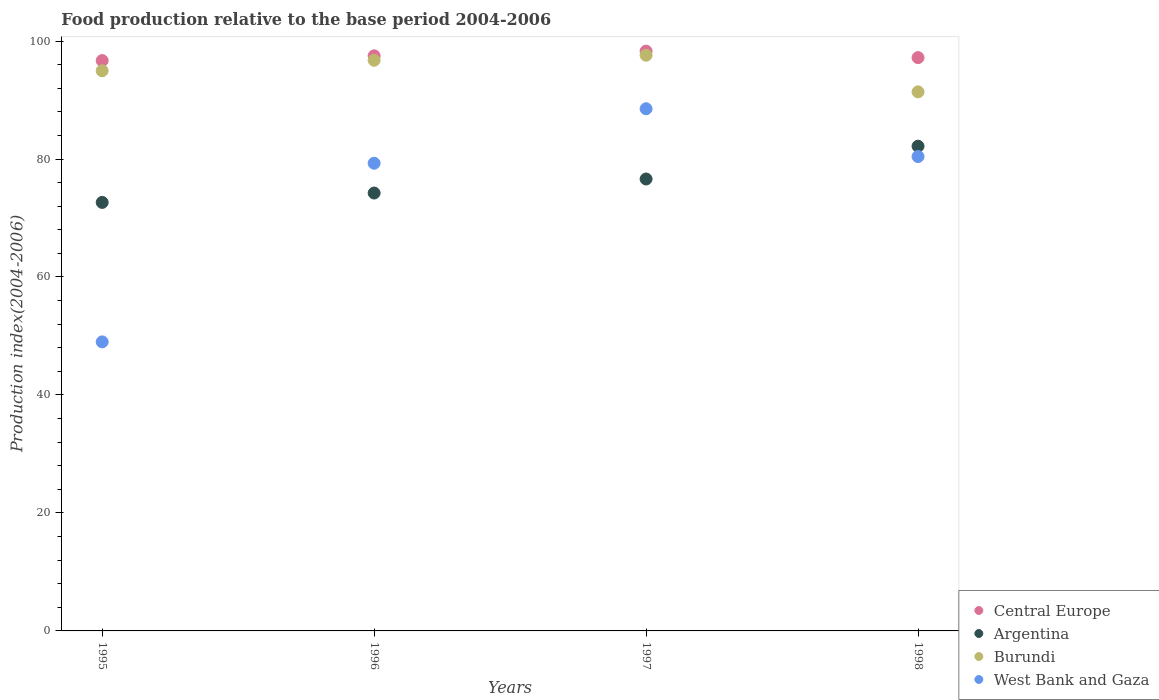How many different coloured dotlines are there?
Provide a succinct answer. 4. Is the number of dotlines equal to the number of legend labels?
Ensure brevity in your answer.  Yes. What is the food production index in Argentina in 1996?
Give a very brief answer. 74.23. Across all years, what is the maximum food production index in Central Europe?
Keep it short and to the point. 98.29. Across all years, what is the minimum food production index in Argentina?
Your answer should be compact. 72.64. In which year was the food production index in Burundi minimum?
Your response must be concise. 1998. What is the total food production index in Central Europe in the graph?
Offer a terse response. 389.66. What is the difference between the food production index in West Bank and Gaza in 1995 and that in 1997?
Your answer should be compact. -39.52. What is the difference between the food production index in West Bank and Gaza in 1998 and the food production index in Central Europe in 1997?
Make the answer very short. -17.87. What is the average food production index in West Bank and Gaza per year?
Your answer should be compact. 74.31. In the year 1995, what is the difference between the food production index in Argentina and food production index in Central Europe?
Give a very brief answer. -24.04. In how many years, is the food production index in Central Europe greater than 28?
Your answer should be very brief. 4. What is the ratio of the food production index in West Bank and Gaza in 1995 to that in 1996?
Provide a succinct answer. 0.62. Is the food production index in Burundi in 1995 less than that in 1997?
Give a very brief answer. Yes. Is the difference between the food production index in Argentina in 1995 and 1996 greater than the difference between the food production index in Central Europe in 1995 and 1996?
Keep it short and to the point. No. What is the difference between the highest and the second highest food production index in West Bank and Gaza?
Your response must be concise. 8.1. What is the difference between the highest and the lowest food production index in Central Europe?
Give a very brief answer. 1.61. Is the sum of the food production index in West Bank and Gaza in 1995 and 1998 greater than the maximum food production index in Argentina across all years?
Keep it short and to the point. Yes. Is the food production index in Argentina strictly less than the food production index in Central Europe over the years?
Ensure brevity in your answer.  Yes. How many dotlines are there?
Provide a short and direct response. 4. What is the difference between two consecutive major ticks on the Y-axis?
Your answer should be very brief. 20. Are the values on the major ticks of Y-axis written in scientific E-notation?
Your response must be concise. No. Does the graph contain any zero values?
Provide a succinct answer. No. How are the legend labels stacked?
Your answer should be compact. Vertical. What is the title of the graph?
Your answer should be very brief. Food production relative to the base period 2004-2006. Does "Mali" appear as one of the legend labels in the graph?
Make the answer very short. No. What is the label or title of the Y-axis?
Your response must be concise. Production index(2004-2006). What is the Production index(2004-2006) of Central Europe in 1995?
Make the answer very short. 96.68. What is the Production index(2004-2006) of Argentina in 1995?
Offer a very short reply. 72.64. What is the Production index(2004-2006) in Burundi in 1995?
Keep it short and to the point. 94.96. What is the Production index(2004-2006) in Central Europe in 1996?
Make the answer very short. 97.49. What is the Production index(2004-2006) of Argentina in 1996?
Offer a very short reply. 74.23. What is the Production index(2004-2006) in Burundi in 1996?
Make the answer very short. 96.74. What is the Production index(2004-2006) of West Bank and Gaza in 1996?
Offer a very short reply. 79.28. What is the Production index(2004-2006) of Central Europe in 1997?
Provide a short and direct response. 98.29. What is the Production index(2004-2006) in Argentina in 1997?
Your response must be concise. 76.61. What is the Production index(2004-2006) of Burundi in 1997?
Provide a succinct answer. 97.59. What is the Production index(2004-2006) of West Bank and Gaza in 1997?
Provide a succinct answer. 88.52. What is the Production index(2004-2006) in Central Europe in 1998?
Keep it short and to the point. 97.19. What is the Production index(2004-2006) of Argentina in 1998?
Offer a terse response. 82.17. What is the Production index(2004-2006) in Burundi in 1998?
Keep it short and to the point. 91.38. What is the Production index(2004-2006) in West Bank and Gaza in 1998?
Make the answer very short. 80.42. Across all years, what is the maximum Production index(2004-2006) in Central Europe?
Provide a short and direct response. 98.29. Across all years, what is the maximum Production index(2004-2006) in Argentina?
Your answer should be compact. 82.17. Across all years, what is the maximum Production index(2004-2006) in Burundi?
Your answer should be compact. 97.59. Across all years, what is the maximum Production index(2004-2006) in West Bank and Gaza?
Make the answer very short. 88.52. Across all years, what is the minimum Production index(2004-2006) in Central Europe?
Offer a very short reply. 96.68. Across all years, what is the minimum Production index(2004-2006) in Argentina?
Your answer should be very brief. 72.64. Across all years, what is the minimum Production index(2004-2006) in Burundi?
Give a very brief answer. 91.38. What is the total Production index(2004-2006) of Central Europe in the graph?
Keep it short and to the point. 389.66. What is the total Production index(2004-2006) in Argentina in the graph?
Make the answer very short. 305.65. What is the total Production index(2004-2006) in Burundi in the graph?
Offer a very short reply. 380.67. What is the total Production index(2004-2006) in West Bank and Gaza in the graph?
Give a very brief answer. 297.22. What is the difference between the Production index(2004-2006) in Central Europe in 1995 and that in 1996?
Give a very brief answer. -0.81. What is the difference between the Production index(2004-2006) of Argentina in 1995 and that in 1996?
Provide a succinct answer. -1.59. What is the difference between the Production index(2004-2006) of Burundi in 1995 and that in 1996?
Give a very brief answer. -1.78. What is the difference between the Production index(2004-2006) in West Bank and Gaza in 1995 and that in 1996?
Give a very brief answer. -30.28. What is the difference between the Production index(2004-2006) in Central Europe in 1995 and that in 1997?
Provide a succinct answer. -1.61. What is the difference between the Production index(2004-2006) of Argentina in 1995 and that in 1997?
Offer a terse response. -3.97. What is the difference between the Production index(2004-2006) of Burundi in 1995 and that in 1997?
Your response must be concise. -2.63. What is the difference between the Production index(2004-2006) of West Bank and Gaza in 1995 and that in 1997?
Provide a short and direct response. -39.52. What is the difference between the Production index(2004-2006) in Central Europe in 1995 and that in 1998?
Offer a terse response. -0.5. What is the difference between the Production index(2004-2006) of Argentina in 1995 and that in 1998?
Ensure brevity in your answer.  -9.53. What is the difference between the Production index(2004-2006) of Burundi in 1995 and that in 1998?
Your response must be concise. 3.58. What is the difference between the Production index(2004-2006) of West Bank and Gaza in 1995 and that in 1998?
Ensure brevity in your answer.  -31.42. What is the difference between the Production index(2004-2006) in Central Europe in 1996 and that in 1997?
Offer a terse response. -0.8. What is the difference between the Production index(2004-2006) in Argentina in 1996 and that in 1997?
Make the answer very short. -2.38. What is the difference between the Production index(2004-2006) of Burundi in 1996 and that in 1997?
Provide a short and direct response. -0.85. What is the difference between the Production index(2004-2006) in West Bank and Gaza in 1996 and that in 1997?
Provide a short and direct response. -9.24. What is the difference between the Production index(2004-2006) of Central Europe in 1996 and that in 1998?
Offer a terse response. 0.31. What is the difference between the Production index(2004-2006) in Argentina in 1996 and that in 1998?
Offer a terse response. -7.94. What is the difference between the Production index(2004-2006) in Burundi in 1996 and that in 1998?
Provide a short and direct response. 5.36. What is the difference between the Production index(2004-2006) in West Bank and Gaza in 1996 and that in 1998?
Offer a terse response. -1.14. What is the difference between the Production index(2004-2006) of Central Europe in 1997 and that in 1998?
Make the answer very short. 1.1. What is the difference between the Production index(2004-2006) in Argentina in 1997 and that in 1998?
Your answer should be very brief. -5.56. What is the difference between the Production index(2004-2006) in Burundi in 1997 and that in 1998?
Your answer should be very brief. 6.21. What is the difference between the Production index(2004-2006) in Central Europe in 1995 and the Production index(2004-2006) in Argentina in 1996?
Provide a short and direct response. 22.45. What is the difference between the Production index(2004-2006) in Central Europe in 1995 and the Production index(2004-2006) in Burundi in 1996?
Your answer should be compact. -0.06. What is the difference between the Production index(2004-2006) in Central Europe in 1995 and the Production index(2004-2006) in West Bank and Gaza in 1996?
Your answer should be compact. 17.4. What is the difference between the Production index(2004-2006) in Argentina in 1995 and the Production index(2004-2006) in Burundi in 1996?
Provide a succinct answer. -24.1. What is the difference between the Production index(2004-2006) in Argentina in 1995 and the Production index(2004-2006) in West Bank and Gaza in 1996?
Keep it short and to the point. -6.64. What is the difference between the Production index(2004-2006) in Burundi in 1995 and the Production index(2004-2006) in West Bank and Gaza in 1996?
Keep it short and to the point. 15.68. What is the difference between the Production index(2004-2006) of Central Europe in 1995 and the Production index(2004-2006) of Argentina in 1997?
Your answer should be very brief. 20.07. What is the difference between the Production index(2004-2006) in Central Europe in 1995 and the Production index(2004-2006) in Burundi in 1997?
Provide a succinct answer. -0.91. What is the difference between the Production index(2004-2006) in Central Europe in 1995 and the Production index(2004-2006) in West Bank and Gaza in 1997?
Your answer should be very brief. 8.16. What is the difference between the Production index(2004-2006) in Argentina in 1995 and the Production index(2004-2006) in Burundi in 1997?
Provide a short and direct response. -24.95. What is the difference between the Production index(2004-2006) of Argentina in 1995 and the Production index(2004-2006) of West Bank and Gaza in 1997?
Give a very brief answer. -15.88. What is the difference between the Production index(2004-2006) in Burundi in 1995 and the Production index(2004-2006) in West Bank and Gaza in 1997?
Keep it short and to the point. 6.44. What is the difference between the Production index(2004-2006) of Central Europe in 1995 and the Production index(2004-2006) of Argentina in 1998?
Make the answer very short. 14.51. What is the difference between the Production index(2004-2006) in Central Europe in 1995 and the Production index(2004-2006) in Burundi in 1998?
Offer a terse response. 5.3. What is the difference between the Production index(2004-2006) of Central Europe in 1995 and the Production index(2004-2006) of West Bank and Gaza in 1998?
Provide a short and direct response. 16.26. What is the difference between the Production index(2004-2006) of Argentina in 1995 and the Production index(2004-2006) of Burundi in 1998?
Make the answer very short. -18.74. What is the difference between the Production index(2004-2006) of Argentina in 1995 and the Production index(2004-2006) of West Bank and Gaza in 1998?
Your answer should be compact. -7.78. What is the difference between the Production index(2004-2006) in Burundi in 1995 and the Production index(2004-2006) in West Bank and Gaza in 1998?
Ensure brevity in your answer.  14.54. What is the difference between the Production index(2004-2006) of Central Europe in 1996 and the Production index(2004-2006) of Argentina in 1997?
Make the answer very short. 20.88. What is the difference between the Production index(2004-2006) in Central Europe in 1996 and the Production index(2004-2006) in Burundi in 1997?
Give a very brief answer. -0.1. What is the difference between the Production index(2004-2006) in Central Europe in 1996 and the Production index(2004-2006) in West Bank and Gaza in 1997?
Give a very brief answer. 8.97. What is the difference between the Production index(2004-2006) in Argentina in 1996 and the Production index(2004-2006) in Burundi in 1997?
Offer a very short reply. -23.36. What is the difference between the Production index(2004-2006) in Argentina in 1996 and the Production index(2004-2006) in West Bank and Gaza in 1997?
Provide a short and direct response. -14.29. What is the difference between the Production index(2004-2006) of Burundi in 1996 and the Production index(2004-2006) of West Bank and Gaza in 1997?
Provide a succinct answer. 8.22. What is the difference between the Production index(2004-2006) in Central Europe in 1996 and the Production index(2004-2006) in Argentina in 1998?
Your answer should be compact. 15.32. What is the difference between the Production index(2004-2006) in Central Europe in 1996 and the Production index(2004-2006) in Burundi in 1998?
Your answer should be compact. 6.11. What is the difference between the Production index(2004-2006) of Central Europe in 1996 and the Production index(2004-2006) of West Bank and Gaza in 1998?
Your response must be concise. 17.07. What is the difference between the Production index(2004-2006) of Argentina in 1996 and the Production index(2004-2006) of Burundi in 1998?
Make the answer very short. -17.15. What is the difference between the Production index(2004-2006) in Argentina in 1996 and the Production index(2004-2006) in West Bank and Gaza in 1998?
Give a very brief answer. -6.19. What is the difference between the Production index(2004-2006) in Burundi in 1996 and the Production index(2004-2006) in West Bank and Gaza in 1998?
Your answer should be compact. 16.32. What is the difference between the Production index(2004-2006) in Central Europe in 1997 and the Production index(2004-2006) in Argentina in 1998?
Make the answer very short. 16.12. What is the difference between the Production index(2004-2006) of Central Europe in 1997 and the Production index(2004-2006) of Burundi in 1998?
Provide a succinct answer. 6.91. What is the difference between the Production index(2004-2006) of Central Europe in 1997 and the Production index(2004-2006) of West Bank and Gaza in 1998?
Your answer should be compact. 17.87. What is the difference between the Production index(2004-2006) of Argentina in 1997 and the Production index(2004-2006) of Burundi in 1998?
Offer a very short reply. -14.77. What is the difference between the Production index(2004-2006) of Argentina in 1997 and the Production index(2004-2006) of West Bank and Gaza in 1998?
Make the answer very short. -3.81. What is the difference between the Production index(2004-2006) in Burundi in 1997 and the Production index(2004-2006) in West Bank and Gaza in 1998?
Offer a terse response. 17.17. What is the average Production index(2004-2006) of Central Europe per year?
Your answer should be very brief. 97.41. What is the average Production index(2004-2006) of Argentina per year?
Your answer should be compact. 76.41. What is the average Production index(2004-2006) in Burundi per year?
Provide a succinct answer. 95.17. What is the average Production index(2004-2006) in West Bank and Gaza per year?
Keep it short and to the point. 74.31. In the year 1995, what is the difference between the Production index(2004-2006) of Central Europe and Production index(2004-2006) of Argentina?
Provide a short and direct response. 24.04. In the year 1995, what is the difference between the Production index(2004-2006) in Central Europe and Production index(2004-2006) in Burundi?
Keep it short and to the point. 1.72. In the year 1995, what is the difference between the Production index(2004-2006) of Central Europe and Production index(2004-2006) of West Bank and Gaza?
Keep it short and to the point. 47.68. In the year 1995, what is the difference between the Production index(2004-2006) in Argentina and Production index(2004-2006) in Burundi?
Provide a short and direct response. -22.32. In the year 1995, what is the difference between the Production index(2004-2006) of Argentina and Production index(2004-2006) of West Bank and Gaza?
Your answer should be compact. 23.64. In the year 1995, what is the difference between the Production index(2004-2006) of Burundi and Production index(2004-2006) of West Bank and Gaza?
Offer a terse response. 45.96. In the year 1996, what is the difference between the Production index(2004-2006) in Central Europe and Production index(2004-2006) in Argentina?
Offer a very short reply. 23.26. In the year 1996, what is the difference between the Production index(2004-2006) of Central Europe and Production index(2004-2006) of Burundi?
Make the answer very short. 0.75. In the year 1996, what is the difference between the Production index(2004-2006) in Central Europe and Production index(2004-2006) in West Bank and Gaza?
Your answer should be compact. 18.21. In the year 1996, what is the difference between the Production index(2004-2006) in Argentina and Production index(2004-2006) in Burundi?
Make the answer very short. -22.51. In the year 1996, what is the difference between the Production index(2004-2006) of Argentina and Production index(2004-2006) of West Bank and Gaza?
Your response must be concise. -5.05. In the year 1996, what is the difference between the Production index(2004-2006) of Burundi and Production index(2004-2006) of West Bank and Gaza?
Your response must be concise. 17.46. In the year 1997, what is the difference between the Production index(2004-2006) of Central Europe and Production index(2004-2006) of Argentina?
Give a very brief answer. 21.68. In the year 1997, what is the difference between the Production index(2004-2006) in Central Europe and Production index(2004-2006) in Burundi?
Your response must be concise. 0.7. In the year 1997, what is the difference between the Production index(2004-2006) in Central Europe and Production index(2004-2006) in West Bank and Gaza?
Ensure brevity in your answer.  9.77. In the year 1997, what is the difference between the Production index(2004-2006) of Argentina and Production index(2004-2006) of Burundi?
Make the answer very short. -20.98. In the year 1997, what is the difference between the Production index(2004-2006) in Argentina and Production index(2004-2006) in West Bank and Gaza?
Offer a terse response. -11.91. In the year 1997, what is the difference between the Production index(2004-2006) in Burundi and Production index(2004-2006) in West Bank and Gaza?
Provide a succinct answer. 9.07. In the year 1998, what is the difference between the Production index(2004-2006) in Central Europe and Production index(2004-2006) in Argentina?
Your response must be concise. 15.02. In the year 1998, what is the difference between the Production index(2004-2006) in Central Europe and Production index(2004-2006) in Burundi?
Your answer should be very brief. 5.81. In the year 1998, what is the difference between the Production index(2004-2006) in Central Europe and Production index(2004-2006) in West Bank and Gaza?
Give a very brief answer. 16.77. In the year 1998, what is the difference between the Production index(2004-2006) in Argentina and Production index(2004-2006) in Burundi?
Your response must be concise. -9.21. In the year 1998, what is the difference between the Production index(2004-2006) in Burundi and Production index(2004-2006) in West Bank and Gaza?
Keep it short and to the point. 10.96. What is the ratio of the Production index(2004-2006) in Central Europe in 1995 to that in 1996?
Provide a short and direct response. 0.99. What is the ratio of the Production index(2004-2006) of Argentina in 1995 to that in 1996?
Provide a short and direct response. 0.98. What is the ratio of the Production index(2004-2006) of Burundi in 1995 to that in 1996?
Provide a succinct answer. 0.98. What is the ratio of the Production index(2004-2006) in West Bank and Gaza in 1995 to that in 1996?
Your answer should be compact. 0.62. What is the ratio of the Production index(2004-2006) in Central Europe in 1995 to that in 1997?
Your answer should be very brief. 0.98. What is the ratio of the Production index(2004-2006) of Argentina in 1995 to that in 1997?
Your response must be concise. 0.95. What is the ratio of the Production index(2004-2006) of Burundi in 1995 to that in 1997?
Provide a succinct answer. 0.97. What is the ratio of the Production index(2004-2006) of West Bank and Gaza in 1995 to that in 1997?
Ensure brevity in your answer.  0.55. What is the ratio of the Production index(2004-2006) of Argentina in 1995 to that in 1998?
Provide a succinct answer. 0.88. What is the ratio of the Production index(2004-2006) of Burundi in 1995 to that in 1998?
Your response must be concise. 1.04. What is the ratio of the Production index(2004-2006) of West Bank and Gaza in 1995 to that in 1998?
Give a very brief answer. 0.61. What is the ratio of the Production index(2004-2006) of Argentina in 1996 to that in 1997?
Provide a short and direct response. 0.97. What is the ratio of the Production index(2004-2006) of West Bank and Gaza in 1996 to that in 1997?
Give a very brief answer. 0.9. What is the ratio of the Production index(2004-2006) of Argentina in 1996 to that in 1998?
Make the answer very short. 0.9. What is the ratio of the Production index(2004-2006) of Burundi in 1996 to that in 1998?
Ensure brevity in your answer.  1.06. What is the ratio of the Production index(2004-2006) of West Bank and Gaza in 1996 to that in 1998?
Offer a very short reply. 0.99. What is the ratio of the Production index(2004-2006) in Central Europe in 1997 to that in 1998?
Keep it short and to the point. 1.01. What is the ratio of the Production index(2004-2006) of Argentina in 1997 to that in 1998?
Offer a very short reply. 0.93. What is the ratio of the Production index(2004-2006) of Burundi in 1997 to that in 1998?
Your answer should be very brief. 1.07. What is the ratio of the Production index(2004-2006) of West Bank and Gaza in 1997 to that in 1998?
Offer a terse response. 1.1. What is the difference between the highest and the second highest Production index(2004-2006) of Central Europe?
Keep it short and to the point. 0.8. What is the difference between the highest and the second highest Production index(2004-2006) in Argentina?
Give a very brief answer. 5.56. What is the difference between the highest and the lowest Production index(2004-2006) in Central Europe?
Keep it short and to the point. 1.61. What is the difference between the highest and the lowest Production index(2004-2006) of Argentina?
Provide a succinct answer. 9.53. What is the difference between the highest and the lowest Production index(2004-2006) in Burundi?
Make the answer very short. 6.21. What is the difference between the highest and the lowest Production index(2004-2006) of West Bank and Gaza?
Ensure brevity in your answer.  39.52. 